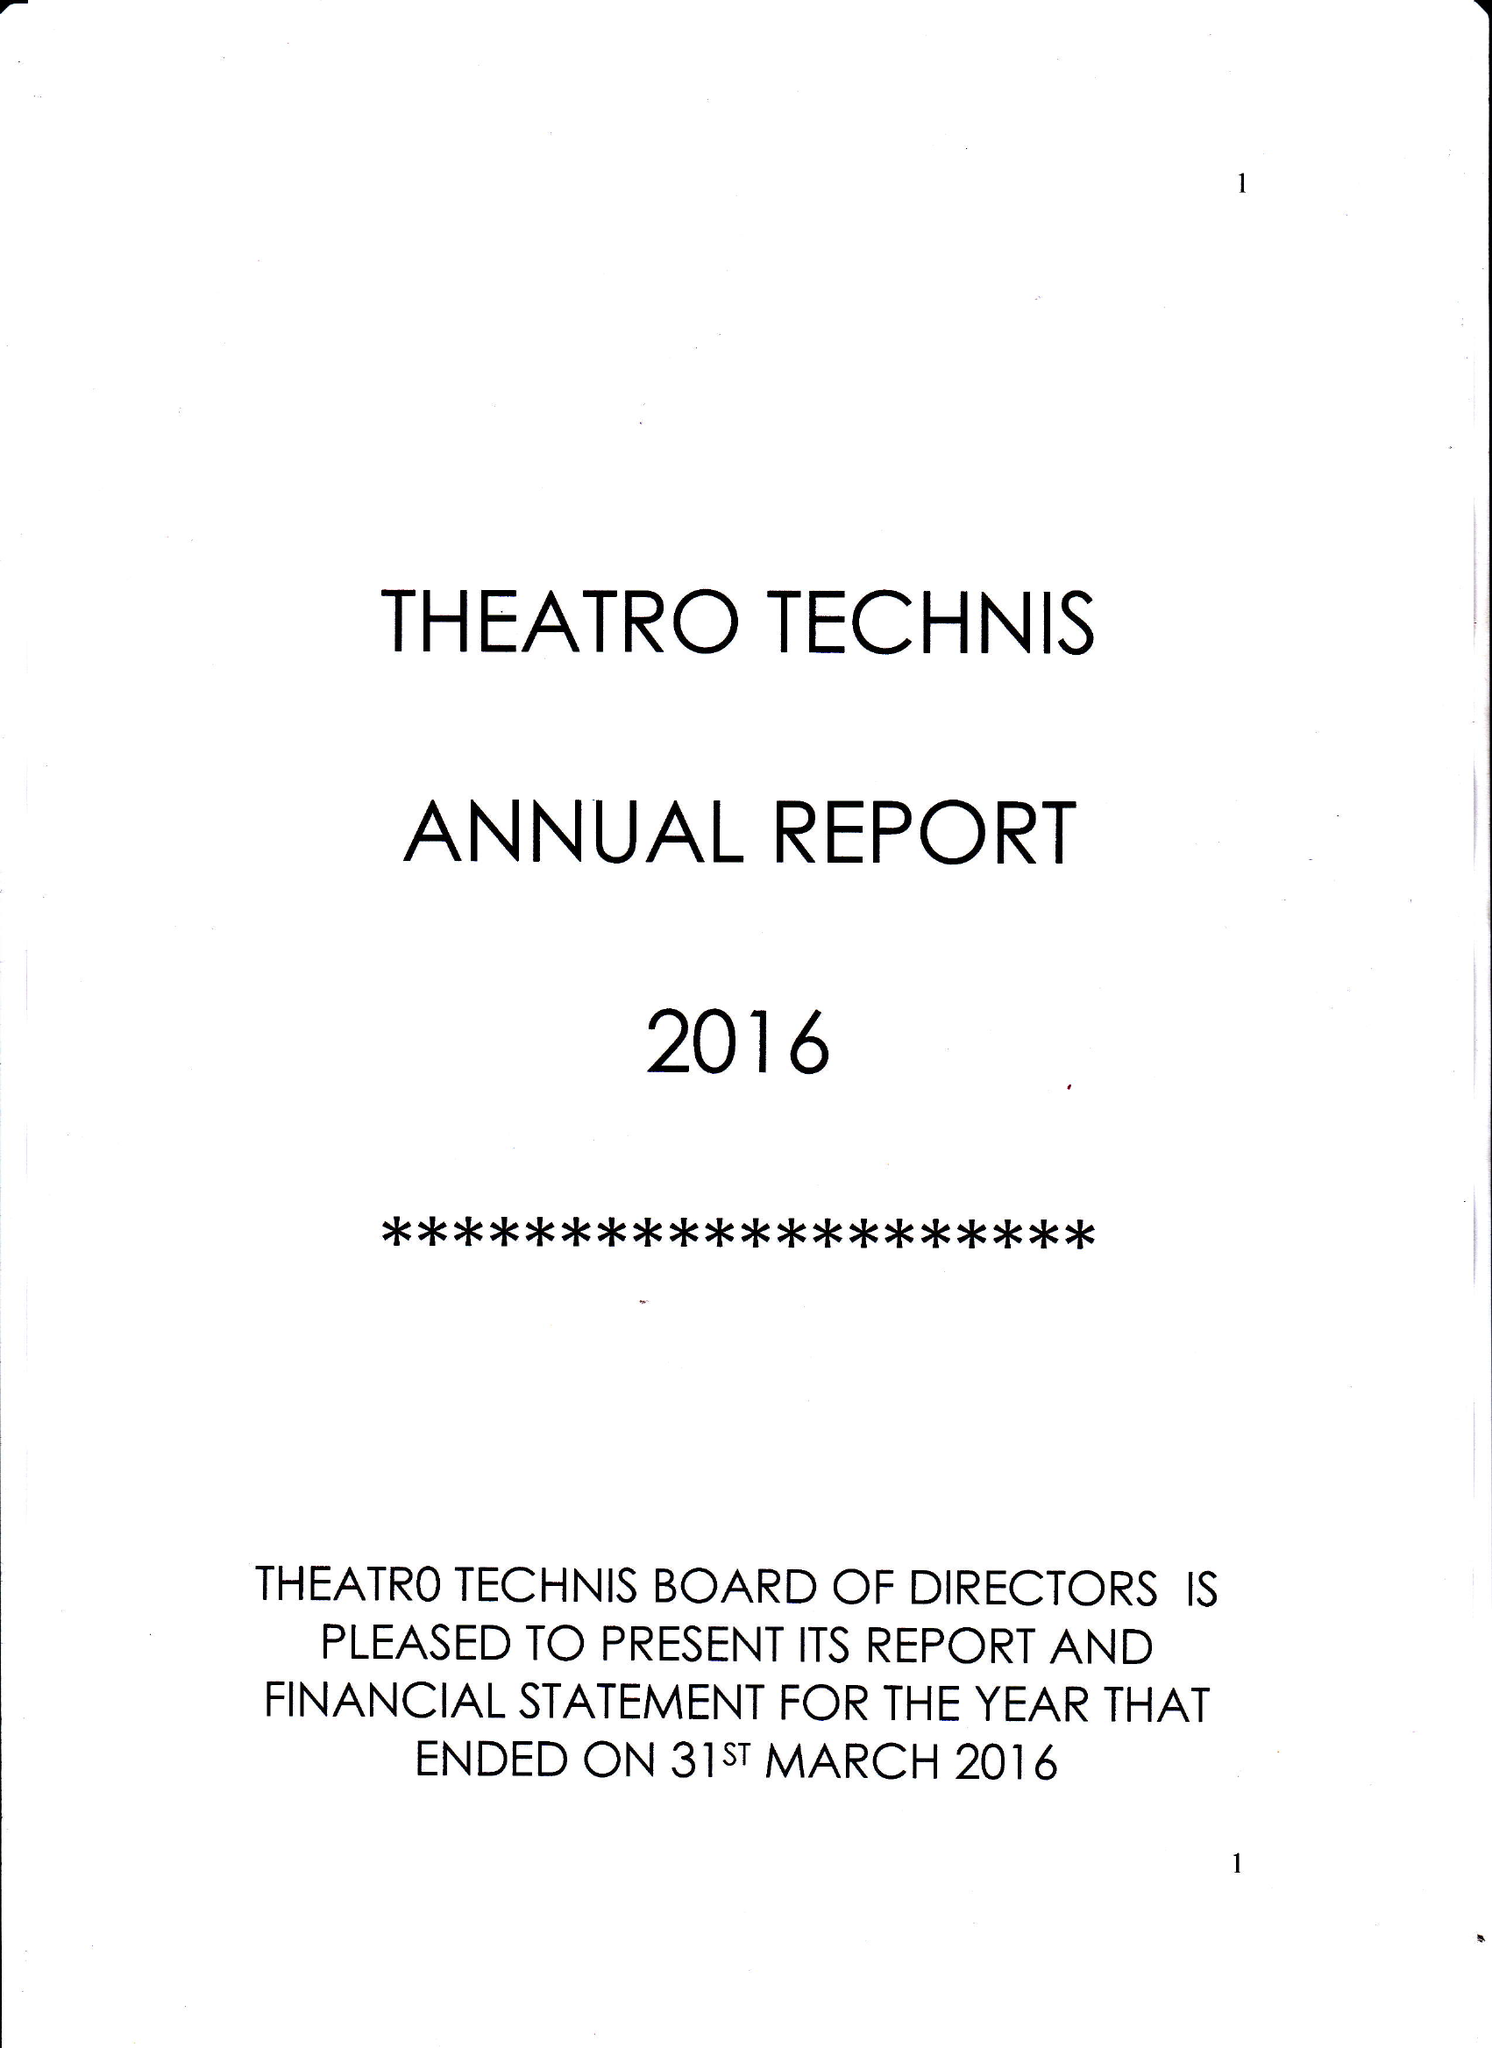What is the value for the spending_annually_in_british_pounds?
Answer the question using a single word or phrase. 95268.00 